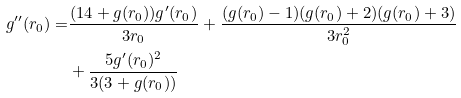Convert formula to latex. <formula><loc_0><loc_0><loc_500><loc_500>g ^ { \prime \prime } ( r _ { 0 } ) = & \frac { ( 1 4 + g ( r _ { 0 } ) ) g ^ { \prime } ( r _ { 0 } ) } { 3 r _ { 0 } } + \frac { ( g ( r _ { 0 } ) - 1 ) ( g ( r _ { 0 } ) + 2 ) ( g ( r _ { 0 } ) + 3 ) } { 3 r _ { 0 } ^ { 2 } } \\ & + \frac { 5 g ^ { \prime } ( r _ { 0 } ) ^ { 2 } } { 3 ( 3 + g ( r _ { 0 } ) ) }</formula> 